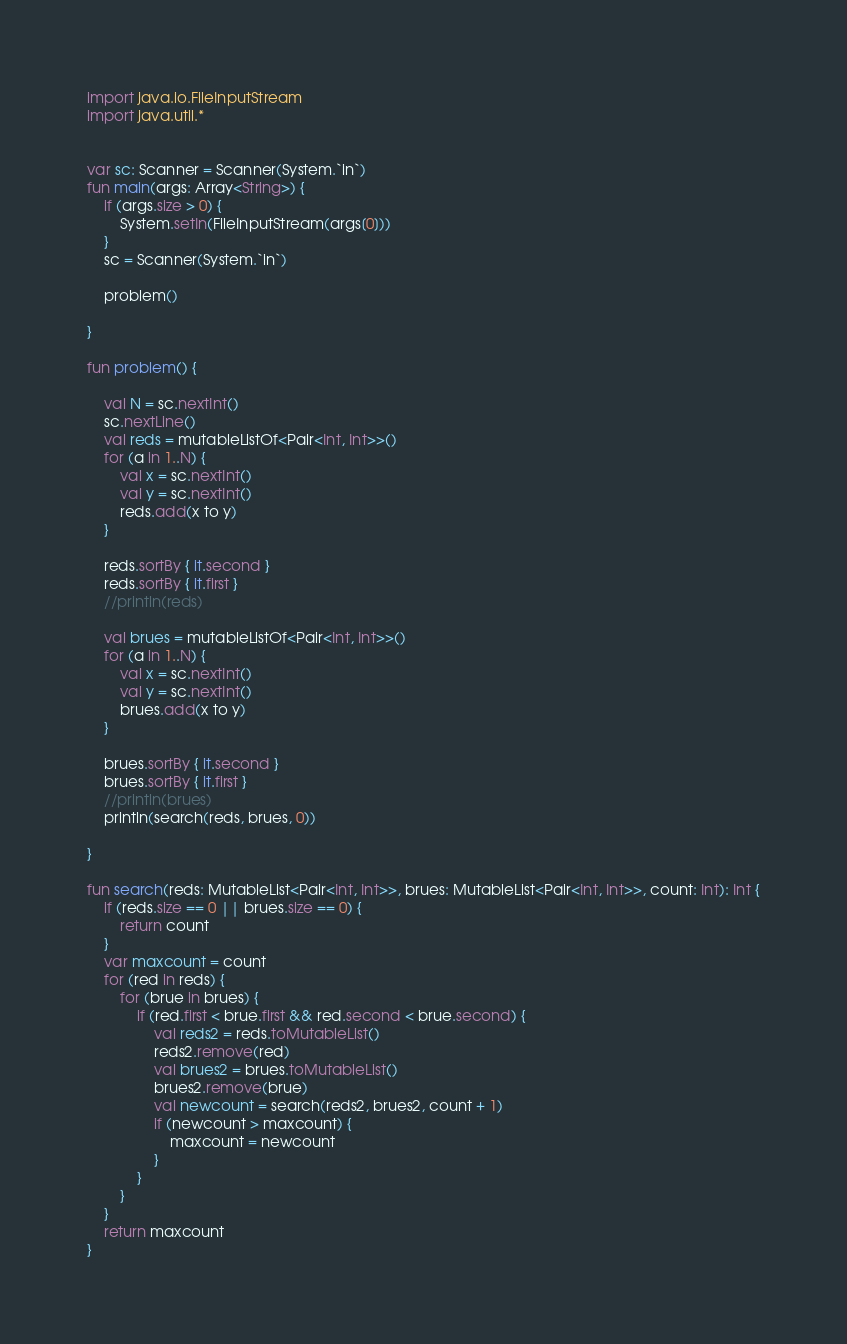Convert code to text. <code><loc_0><loc_0><loc_500><loc_500><_Kotlin_>import java.io.FileInputStream
import java.util.*


var sc: Scanner = Scanner(System.`in`)
fun main(args: Array<String>) {
    if (args.size > 0) {
        System.setIn(FileInputStream(args[0]))
    }
    sc = Scanner(System.`in`)

    problem()

}

fun problem() {

    val N = sc.nextInt()
    sc.nextLine()
    val reds = mutableListOf<Pair<Int, Int>>()
    for (a in 1..N) {
        val x = sc.nextInt()
        val y = sc.nextInt()
        reds.add(x to y)
    }

    reds.sortBy { it.second }
    reds.sortBy { it.first }
    //println(reds)

    val brues = mutableListOf<Pair<Int, Int>>()
    for (a in 1..N) {
        val x = sc.nextInt()
        val y = sc.nextInt()
        brues.add(x to y)
    }

    brues.sortBy { it.second }
    brues.sortBy { it.first }
    //println(brues)
    println(search(reds, brues, 0))

}

fun search(reds: MutableList<Pair<Int, Int>>, brues: MutableList<Pair<Int, Int>>, count: Int): Int {
    if (reds.size == 0 || brues.size == 0) {
        return count
    }
    var maxcount = count
    for (red in reds) {
        for (brue in brues) {
            if (red.first < brue.first && red.second < brue.second) {
                val reds2 = reds.toMutableList()
                reds2.remove(red)
                val brues2 = brues.toMutableList()
                brues2.remove(brue)
                val newcount = search(reds2, brues2, count + 1)
                if (newcount > maxcount) {
                    maxcount = newcount
                }
            }
        }
    }
    return maxcount
}
</code> 